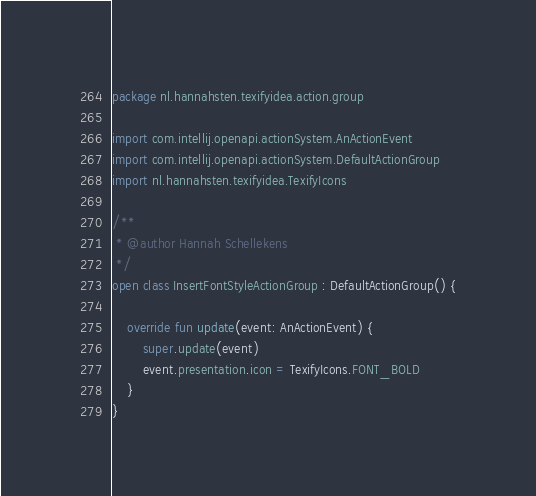Convert code to text. <code><loc_0><loc_0><loc_500><loc_500><_Kotlin_>package nl.hannahsten.texifyidea.action.group

import com.intellij.openapi.actionSystem.AnActionEvent
import com.intellij.openapi.actionSystem.DefaultActionGroup
import nl.hannahsten.texifyidea.TexifyIcons

/**
 * @author Hannah Schellekens
 */
open class InsertFontStyleActionGroup : DefaultActionGroup() {

    override fun update(event: AnActionEvent) {
        super.update(event)
        event.presentation.icon = TexifyIcons.FONT_BOLD
    }
}
</code> 